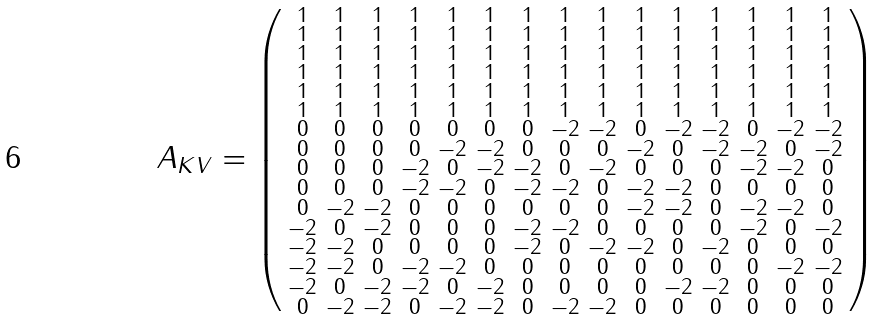<formula> <loc_0><loc_0><loc_500><loc_500>A _ { K V } = \left ( \begin{smallmatrix} 1 & 1 & 1 & 1 & 1 & 1 & 1 & 1 & 1 & 1 & 1 & 1 & 1 & 1 & 1 \\ 1 & 1 & 1 & 1 & 1 & 1 & 1 & 1 & 1 & 1 & 1 & 1 & 1 & 1 & 1 \\ 1 & 1 & 1 & 1 & 1 & 1 & 1 & 1 & 1 & 1 & 1 & 1 & 1 & 1 & 1 \\ 1 & 1 & 1 & 1 & 1 & 1 & 1 & 1 & 1 & 1 & 1 & 1 & 1 & 1 & 1 \\ 1 & 1 & 1 & 1 & 1 & 1 & 1 & 1 & 1 & 1 & 1 & 1 & 1 & 1 & 1 \\ 1 & 1 & 1 & 1 & 1 & 1 & 1 & 1 & 1 & 1 & 1 & 1 & 1 & 1 & 1 \\ 0 & 0 & 0 & 0 & 0 & 0 & 0 & { - 2 } & { - 2 } & 0 & { - 2 } & { - 2 } & 0 & { - 2 } & { - 2 } \\ 0 & 0 & 0 & 0 & { - 2 } & { - 2 } & 0 & 0 & 0 & { - 2 } & 0 & { - 2 } & { - 2 } & 0 & { - 2 } \\ 0 & 0 & 0 & { - 2 } & 0 & { - 2 } & { - 2 } & 0 & { - 2 } & 0 & 0 & 0 & { - 2 } & { - 2 } & 0 \\ 0 & 0 & 0 & { - 2 } & { - 2 } & 0 & { - 2 } & { - 2 } & 0 & { - 2 } & { - 2 } & 0 & 0 & 0 & 0 \\ 0 & { - 2 } & { - 2 } & 0 & 0 & 0 & 0 & 0 & 0 & { - 2 } & { - 2 } & 0 & { - 2 } & { - 2 } & 0 \\ { - 2 } & 0 & { - 2 } & 0 & 0 & 0 & { - 2 } & { - 2 } & 0 & 0 & 0 & 0 & { - 2 } & 0 & { - 2 } \\ { - 2 } & { - 2 } & 0 & 0 & 0 & 0 & { - 2 } & 0 & { - 2 } & { - 2 } & 0 & { - 2 } & 0 & 0 & 0 \\ { - 2 } & { - 2 } & 0 & { - 2 } & { - 2 } & 0 & 0 & 0 & 0 & 0 & 0 & 0 & 0 & { - 2 } & { - 2 } \\ { - 2 } & 0 & { - 2 } & { - 2 } & 0 & { - 2 } & 0 & 0 & 0 & 0 & { - 2 } & { - 2 } & 0 & 0 & 0 \\ 0 & { - 2 } & { - 2 } & 0 & { - 2 } & { - 2 } & 0 & { - 2 } & { - 2 } & 0 & 0 & 0 & 0 & 0 & 0 \end{smallmatrix} \right )</formula> 